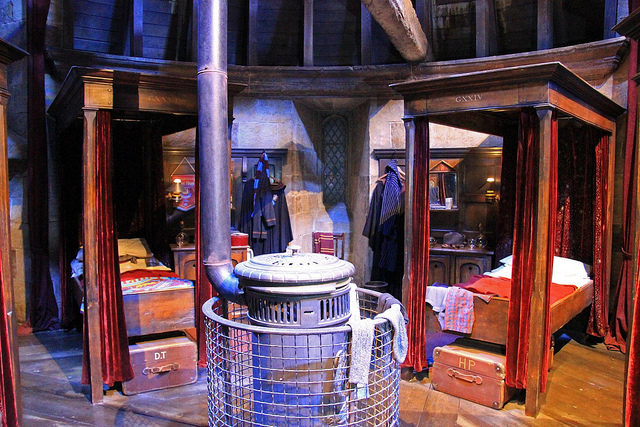What might be the significance of the architecture and decor style seen in this image from Harry Potter? The architecture and decor in the image reflect a medieval European influence, mirroring the historical and magical aspects of Hogwarts. The rustic and sturdy woodwork, coupled with practical yet ancient designs, encapsulate the old-world charm intertwined with magic, representing a place where history and fantasy converge. 